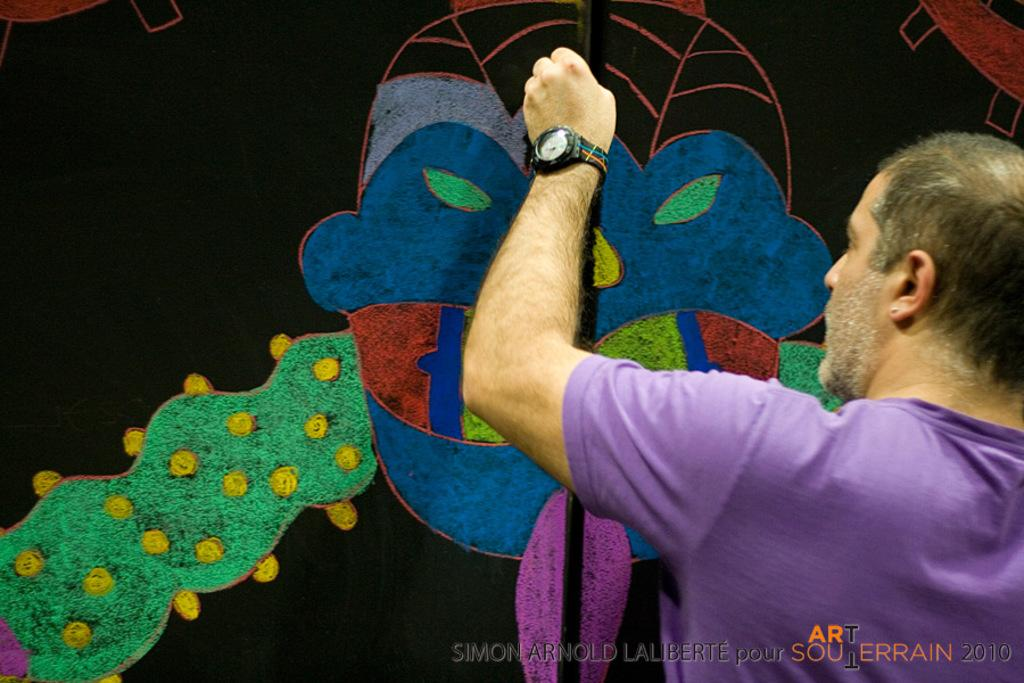Who is the main subject in the image? There is a man in the image. What is the man doing in the image? The man is drawing on a board. What type of meal is being served on the ship in the image? There is no ship or meal present in the image; it only features a man drawing on a board. 